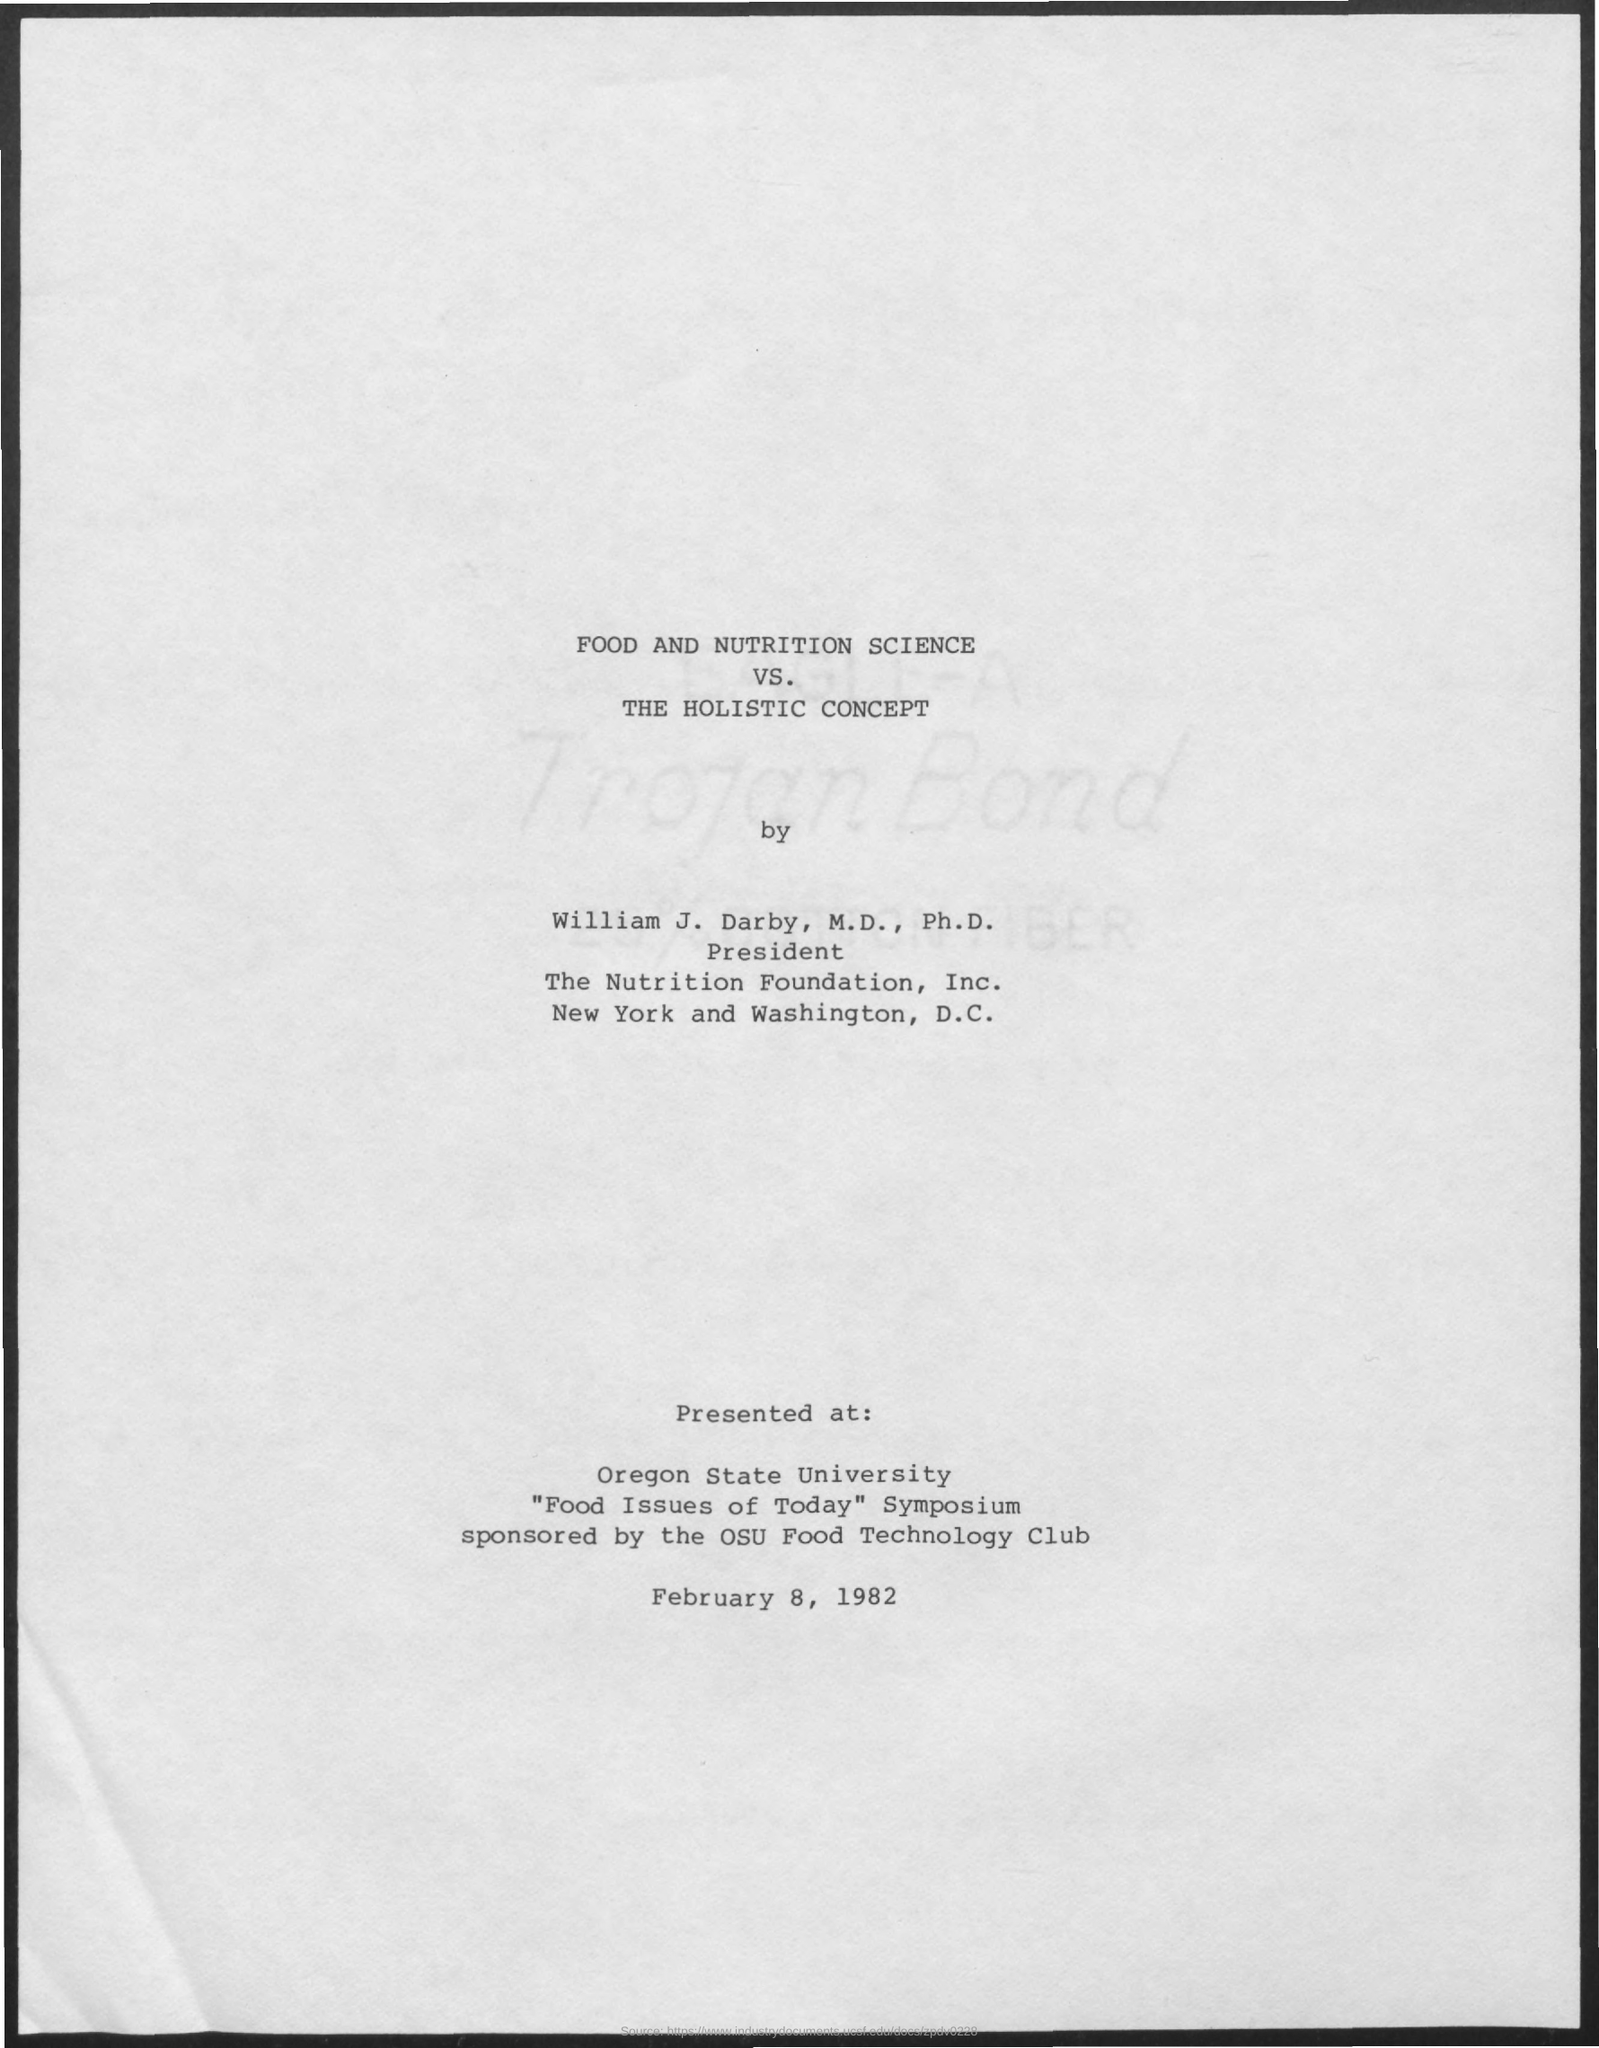Food and Nutrition Science VS. The Holistic Concept is by whom?
Give a very brief answer. William J. Darby, M.D., Ph.D. Where was it presented at?
Give a very brief answer. Oregon state university. Who is it Sponsored by?
Keep it short and to the point. The osu food technology club. When was it presented?
Offer a terse response. February 8, 1982. Where is the The Nutrition Foundation, Inc. located?
Your response must be concise. New York and Washington, d.c. 